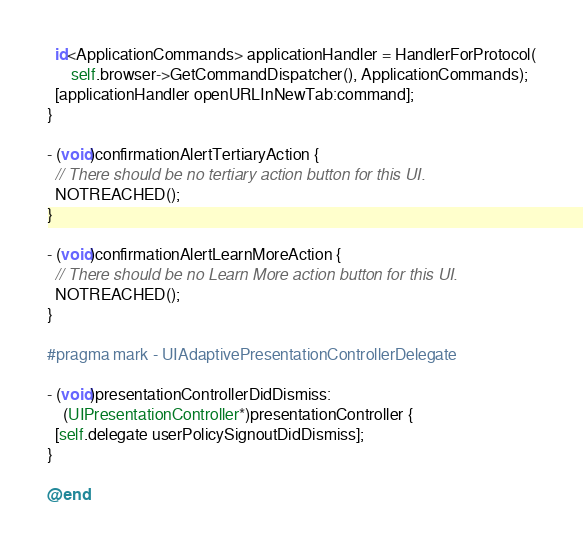<code> <loc_0><loc_0><loc_500><loc_500><_ObjectiveC_>  id<ApplicationCommands> applicationHandler = HandlerForProtocol(
      self.browser->GetCommandDispatcher(), ApplicationCommands);
  [applicationHandler openURLInNewTab:command];
}

- (void)confirmationAlertTertiaryAction {
  // There should be no tertiary action button for this UI.
  NOTREACHED();
}

- (void)confirmationAlertLearnMoreAction {
  // There should be no Learn More action button for this UI.
  NOTREACHED();
}

#pragma mark - UIAdaptivePresentationControllerDelegate

- (void)presentationControllerDidDismiss:
    (UIPresentationController*)presentationController {
  [self.delegate userPolicySignoutDidDismiss];
}

@end
</code> 